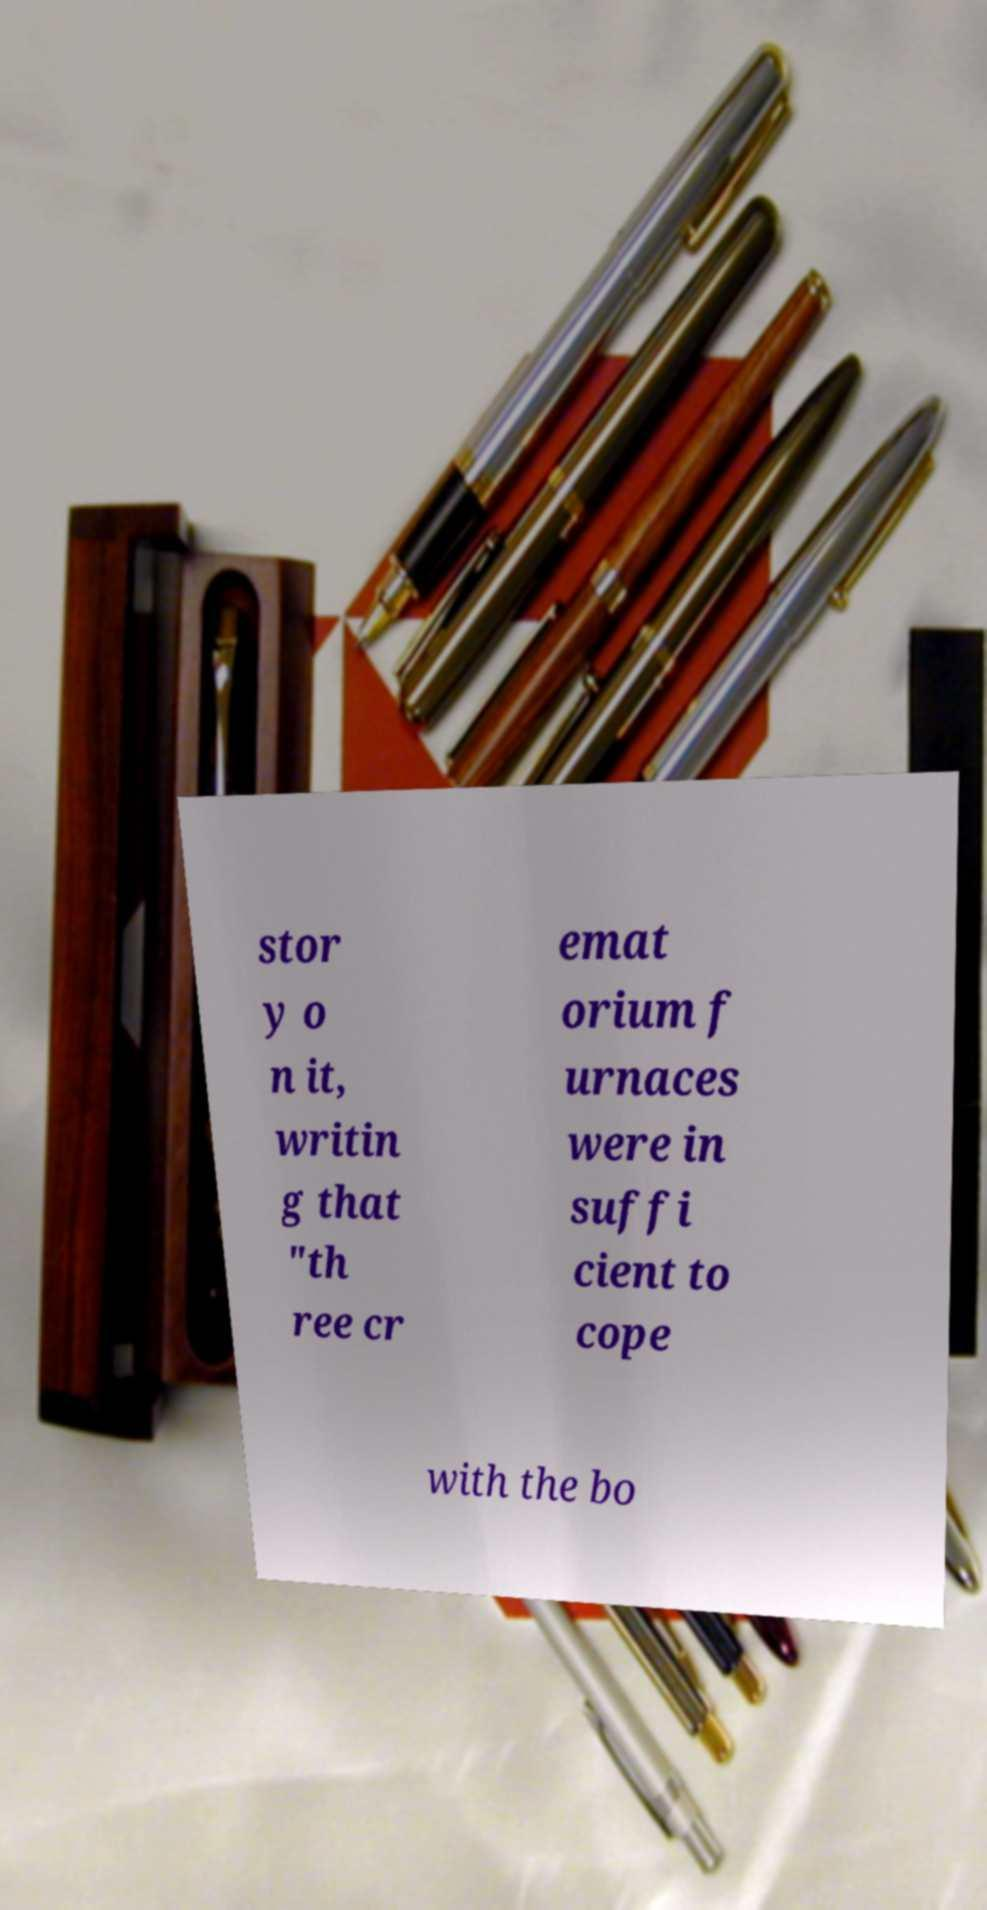For documentation purposes, I need the text within this image transcribed. Could you provide that? stor y o n it, writin g that "th ree cr emat orium f urnaces were in suffi cient to cope with the bo 